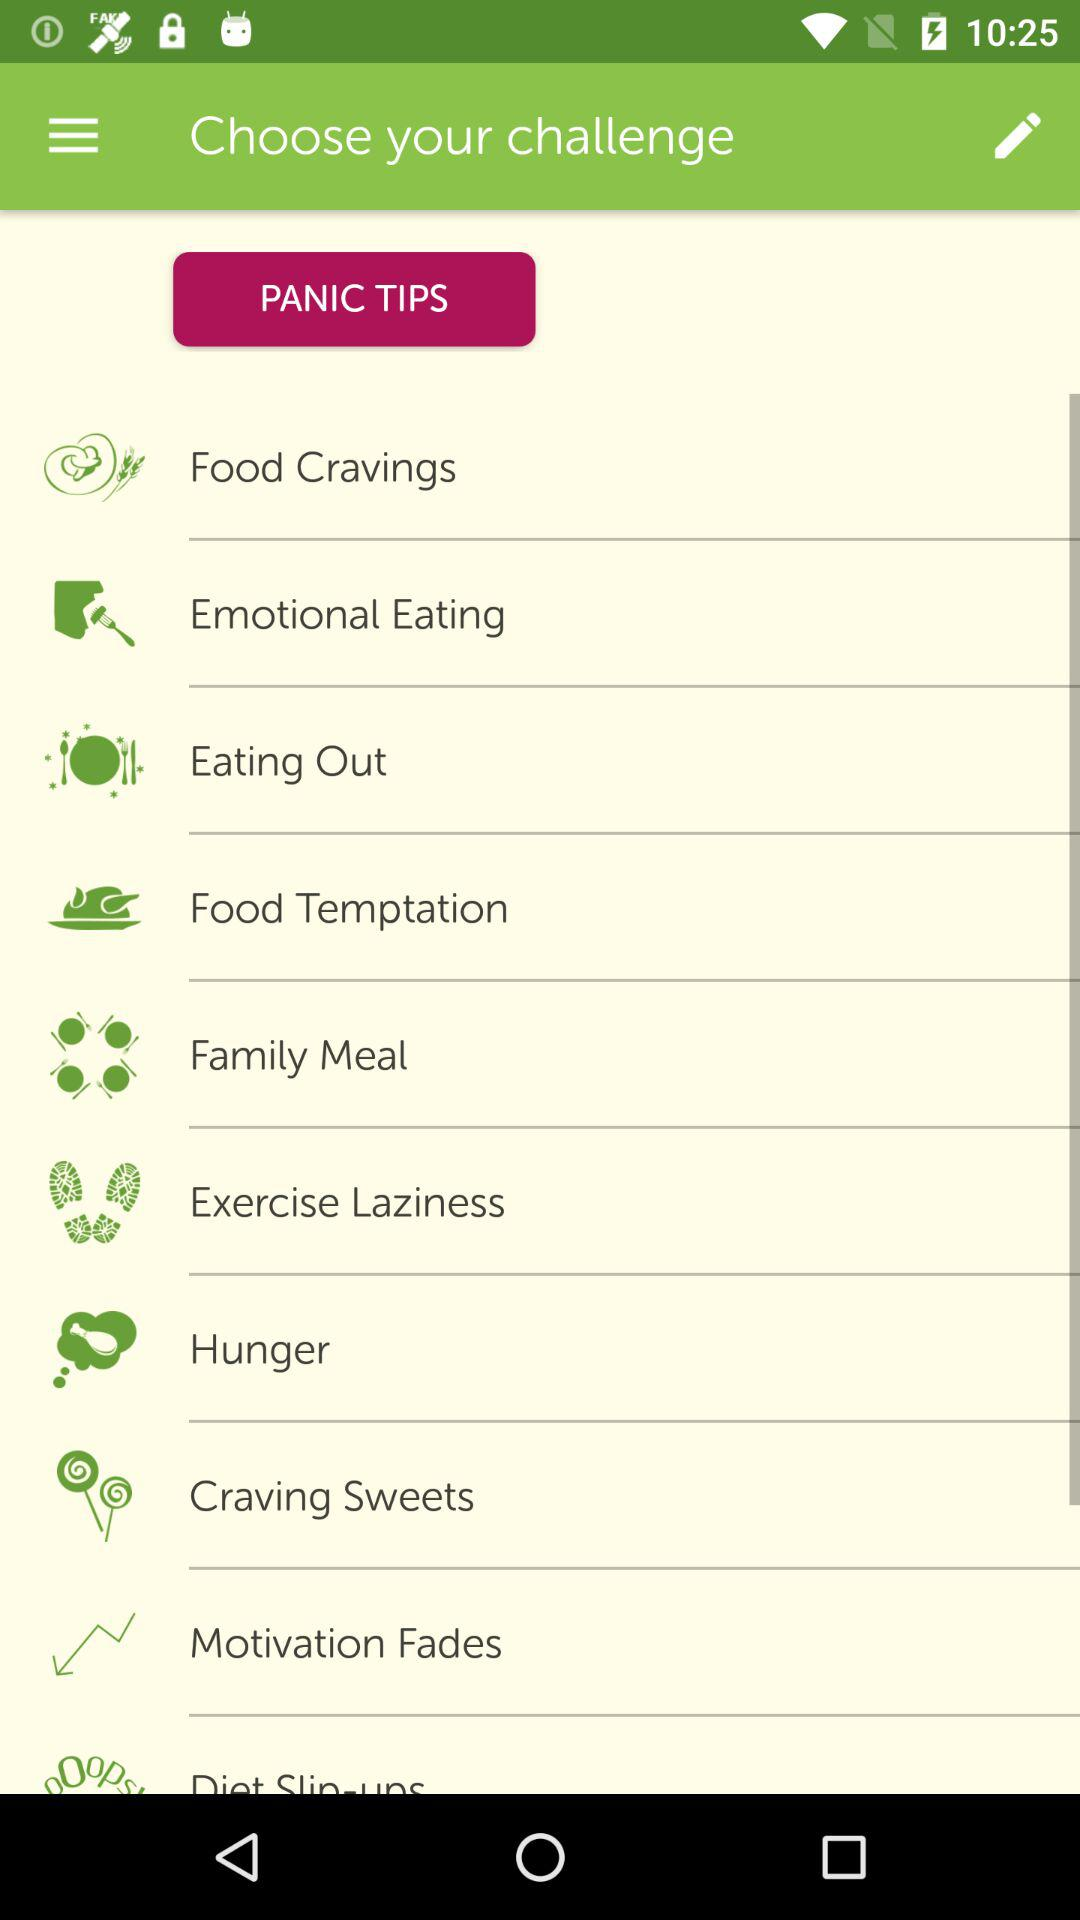How many challenges are there in total?
Answer the question using a single word or phrase. 10 